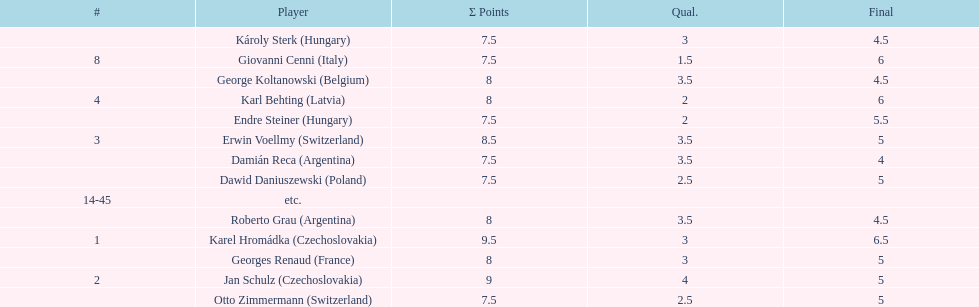How many players tied for 4th place? 4. 